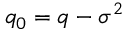Convert formula to latex. <formula><loc_0><loc_0><loc_500><loc_500>q _ { 0 } = q - \sigma ^ { 2 }</formula> 